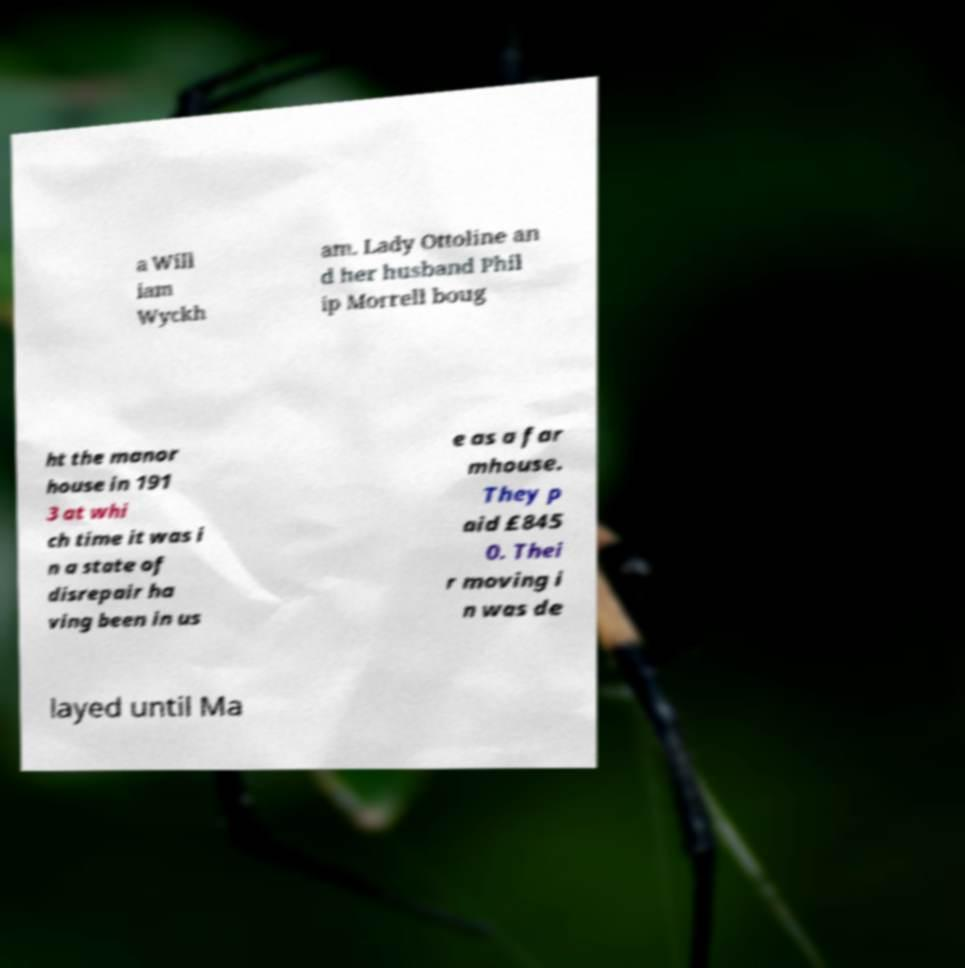Please identify and transcribe the text found in this image. a Will iam Wyckh am. Lady Ottoline an d her husband Phil ip Morrell boug ht the manor house in 191 3 at whi ch time it was i n a state of disrepair ha ving been in us e as a far mhouse. They p aid £845 0. Thei r moving i n was de layed until Ma 